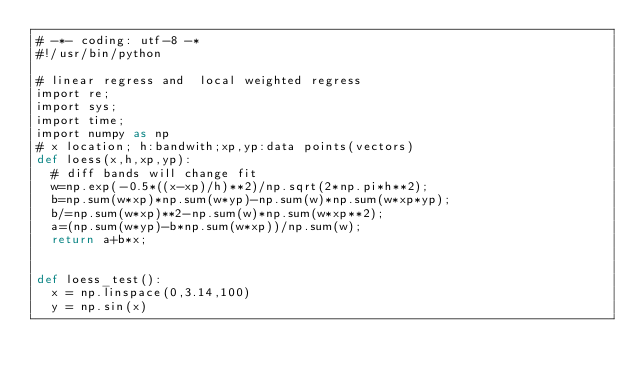<code> <loc_0><loc_0><loc_500><loc_500><_Cython_># -*- coding: utf-8 -*
#!/usr/bin/python

# linear regress and  local weighted regress
import re;
import sys;
import time;
import numpy as np
# x location; h:bandwith;xp,yp:data points(vectors)
def loess(x,h,xp,yp):
	# diff bands will change fit  
	w=np.exp(-0.5*((x-xp)/h)**2)/np.sqrt(2*np.pi*h**2);
	b=np.sum(w*xp)*np.sum(w*yp)-np.sum(w)*np.sum(w*xp*yp);
	b/=np.sum(w*xp)**2-np.sum(w)*np.sum(w*xp**2);
	a=(np.sum(w*yp)-b*np.sum(w*xp))/np.sum(w);
	return a+b*x;


def loess_test():
	x = np.linspace(0,3.14,100)
	y = np.sin(x)



</code> 